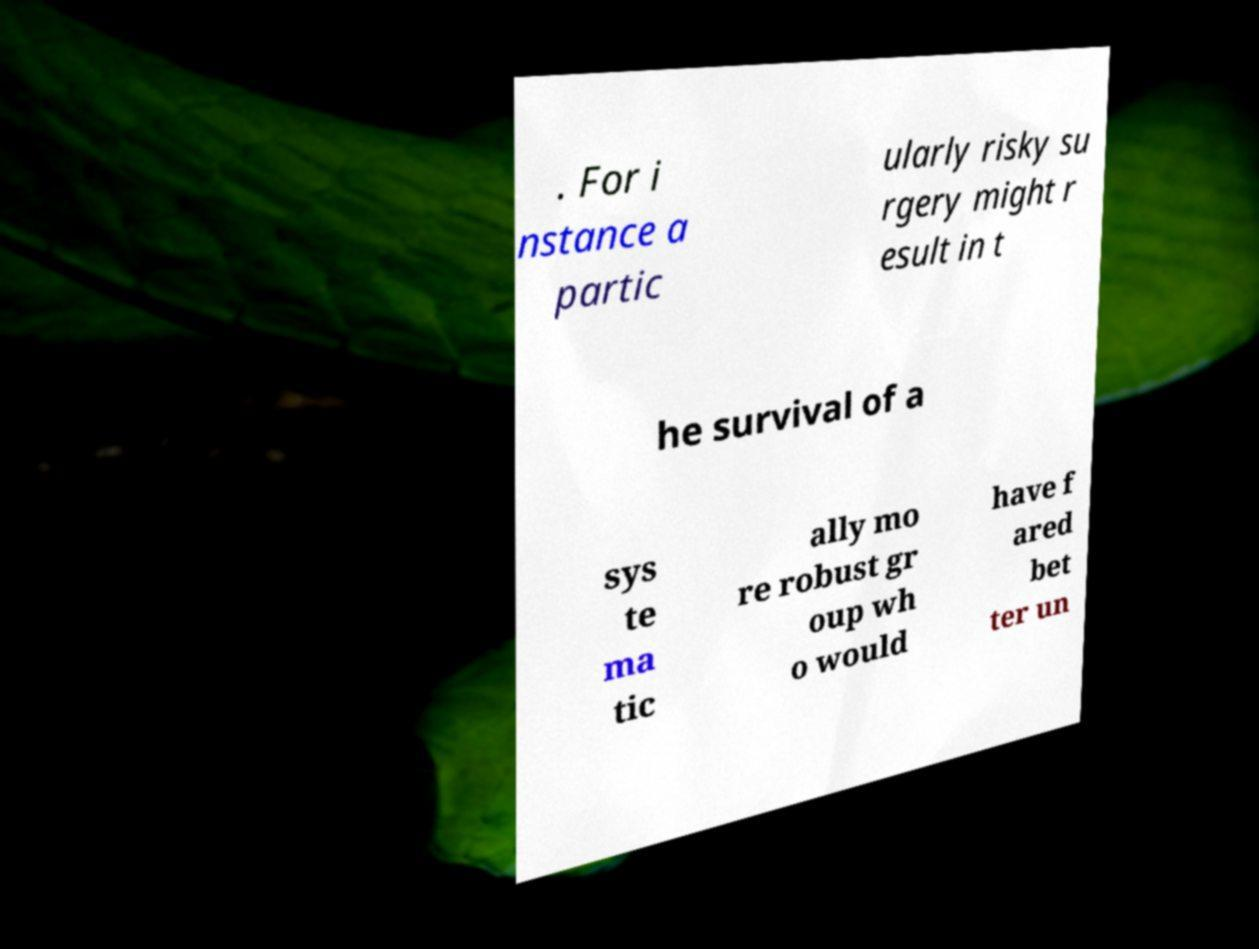Please identify and transcribe the text found in this image. . For i nstance a partic ularly risky su rgery might r esult in t he survival of a sys te ma tic ally mo re robust gr oup wh o would have f ared bet ter un 